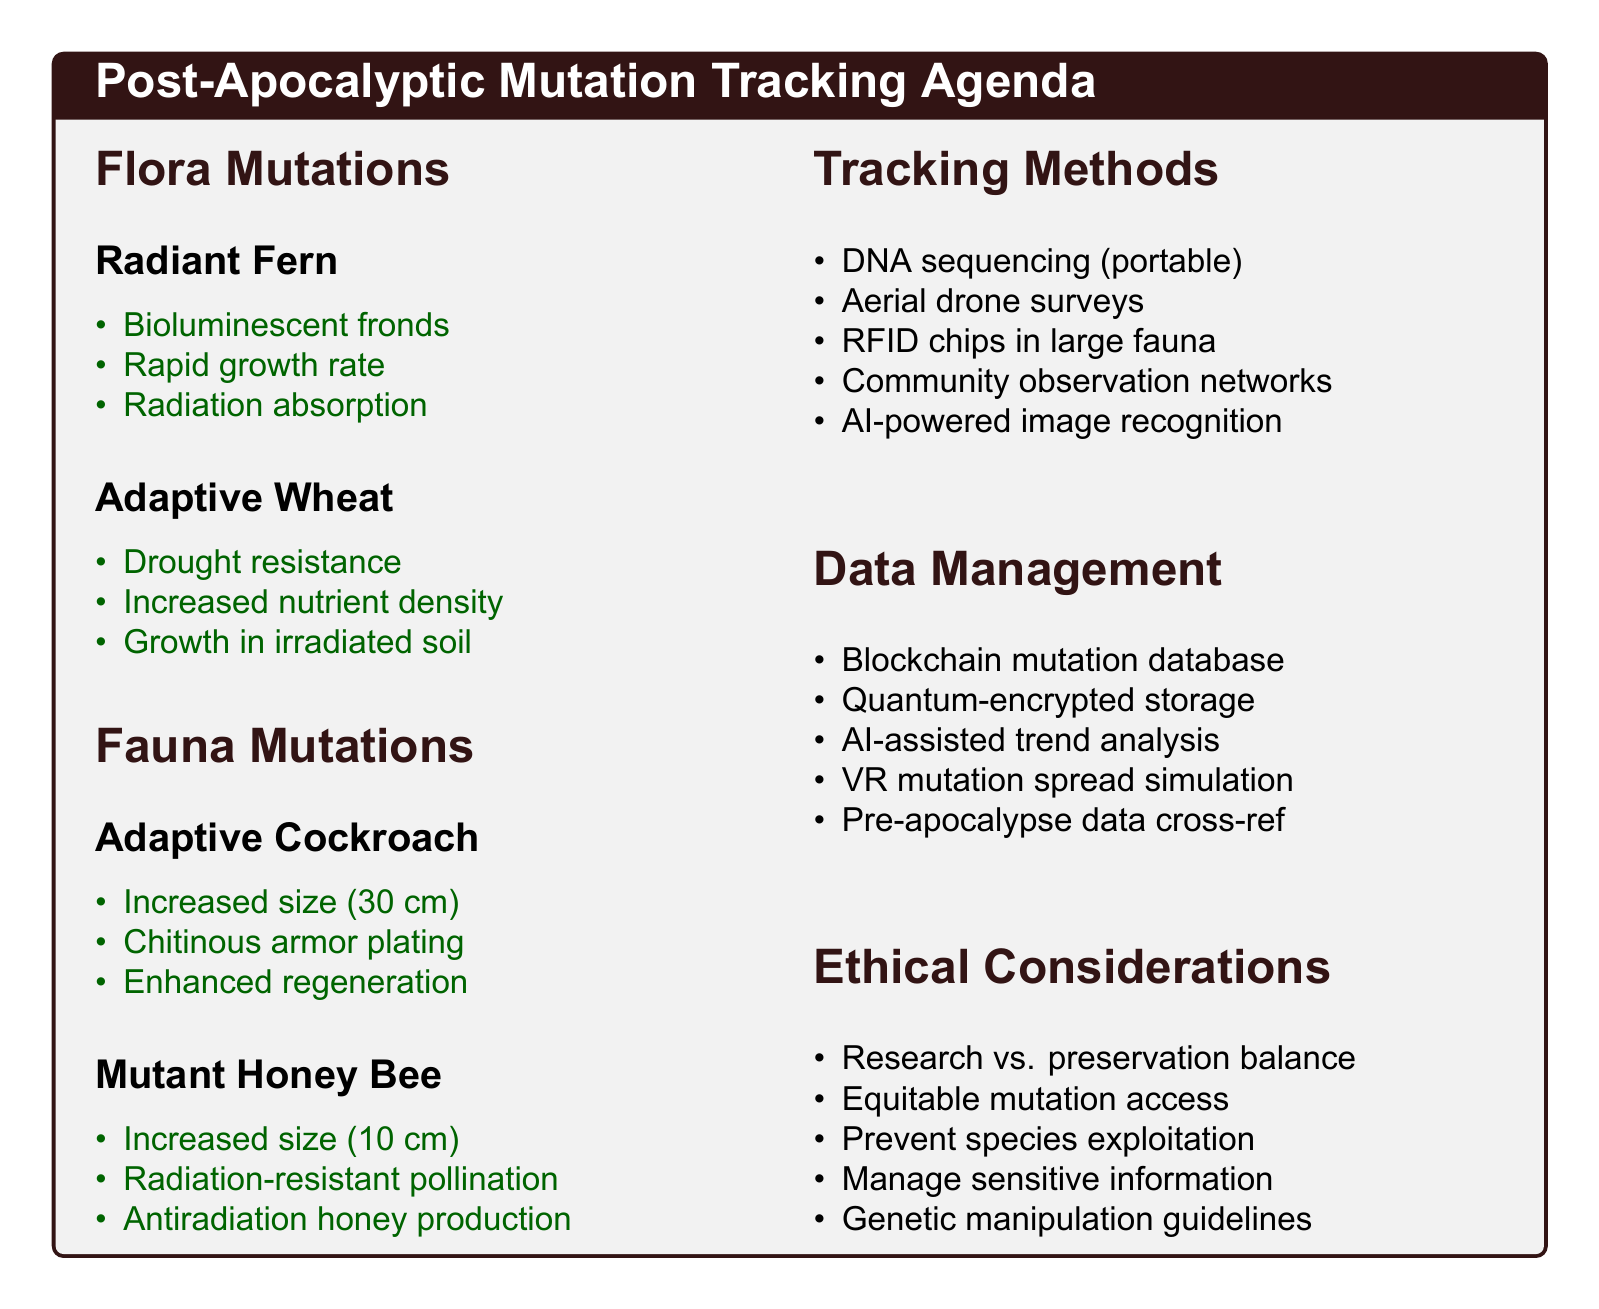What species has observed bioluminescent fronds? The document states that the Radiant Fern is known for its bioluminescent fronds.
Answer: Radiant Fern How many observed mutations does the Adaptive Cockroach have? The Adaptive Cockroach has three observed mutations listed in the document.
Answer: 3 What potential benefit does the Mutant Honey Bee provide? One potential benefit mentioned for the Mutant Honey Bee is that it is crucial for maintaining plant biodiversity.
Answer: Maintaining plant biodiversity Which method utilizes aerial drone surveys? Aerial drone surveys with multispectral imaging are listed as one of the tracking methods.
Answer: Aerial drone surveys What ethical consideration involves research preservation? The document highlights the need for balancing research needs with specimen preservation as an ethical consideration.
Answer: Research vs. preservation balance What is a potential threat of the Adaptive Wheat? The document notes that a potential threat of Adaptive Wheat is that it may outcompete other crops.
Answer: May outcompete other crops 